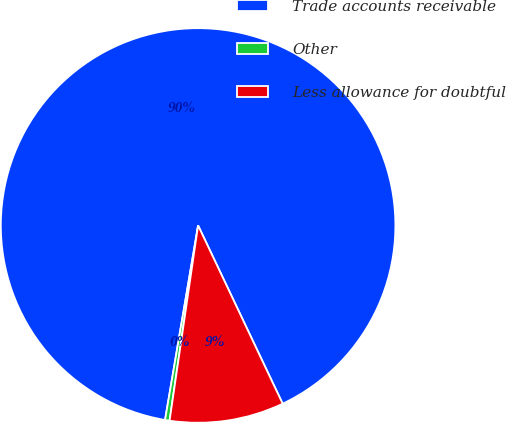<chart> <loc_0><loc_0><loc_500><loc_500><pie_chart><fcel>Trade accounts receivable<fcel>Other<fcel>Less allowance for doubtful<nl><fcel>90.27%<fcel>0.37%<fcel>9.36%<nl></chart> 